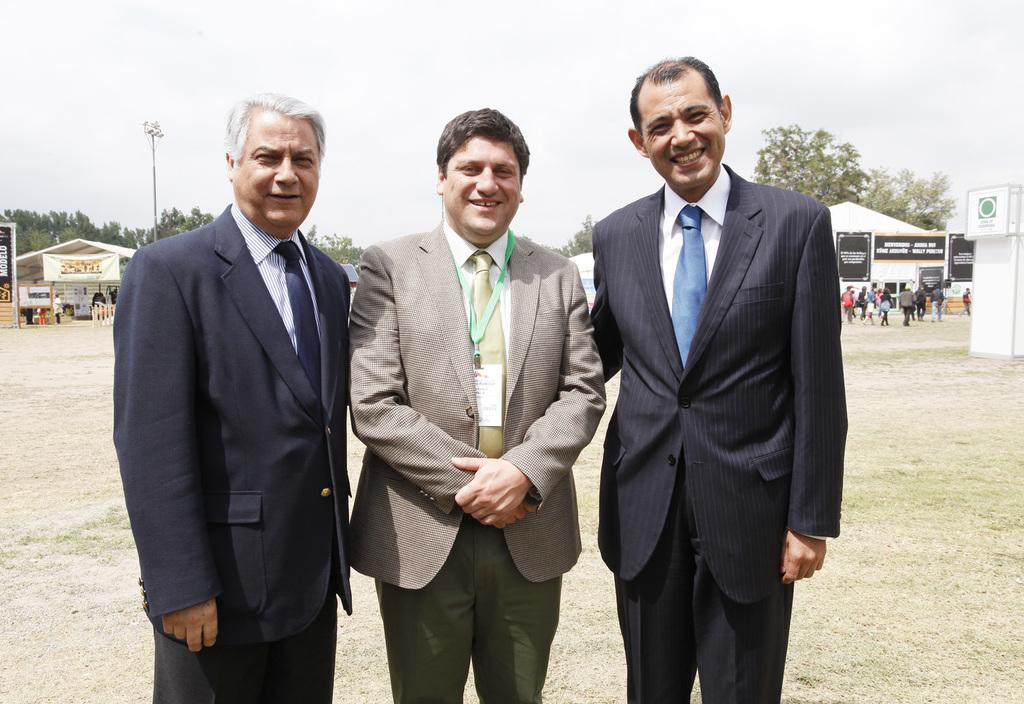How many people are in the image? There are three persons in the image. What are the persons wearing? The persons are wearing suits. Where are the persons standing? The persons are standing on the ground. What can be seen in the background of the image? There are sheds, people, trees, a pole, and the sky visible in the background of the image. What type of nest can be seen in the image? There is no nest present in the image. What color are the trousers worn by the persons in the image? The provided facts do not mention the color of the trousers worn by the persons in the image. 